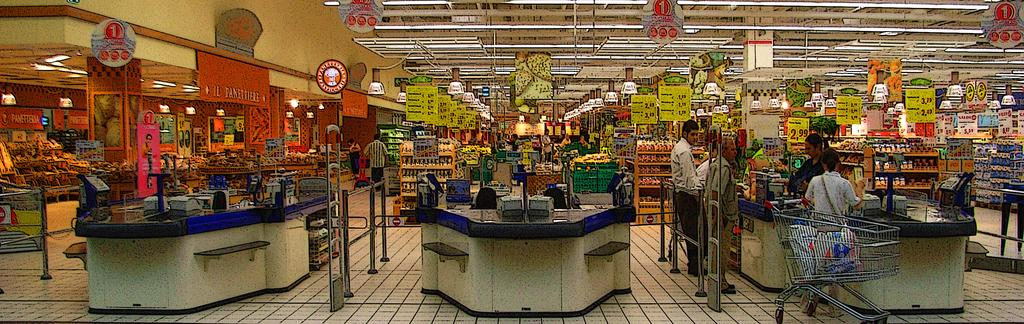<image>
Relay a brief, clear account of the picture shown. a grocery store with several aisles and checkout lanes, and a sign with an orange 1 in the upper left 